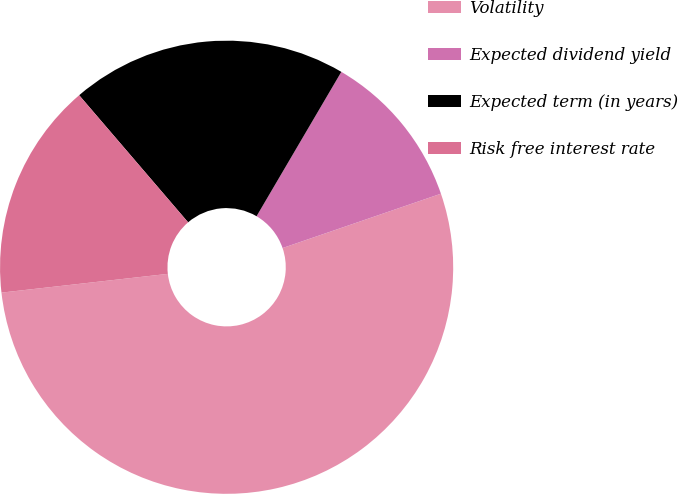Convert chart to OTSL. <chart><loc_0><loc_0><loc_500><loc_500><pie_chart><fcel>Volatility<fcel>Expected dividend yield<fcel>Expected term (in years)<fcel>Risk free interest rate<nl><fcel>53.48%<fcel>11.29%<fcel>19.73%<fcel>15.51%<nl></chart> 